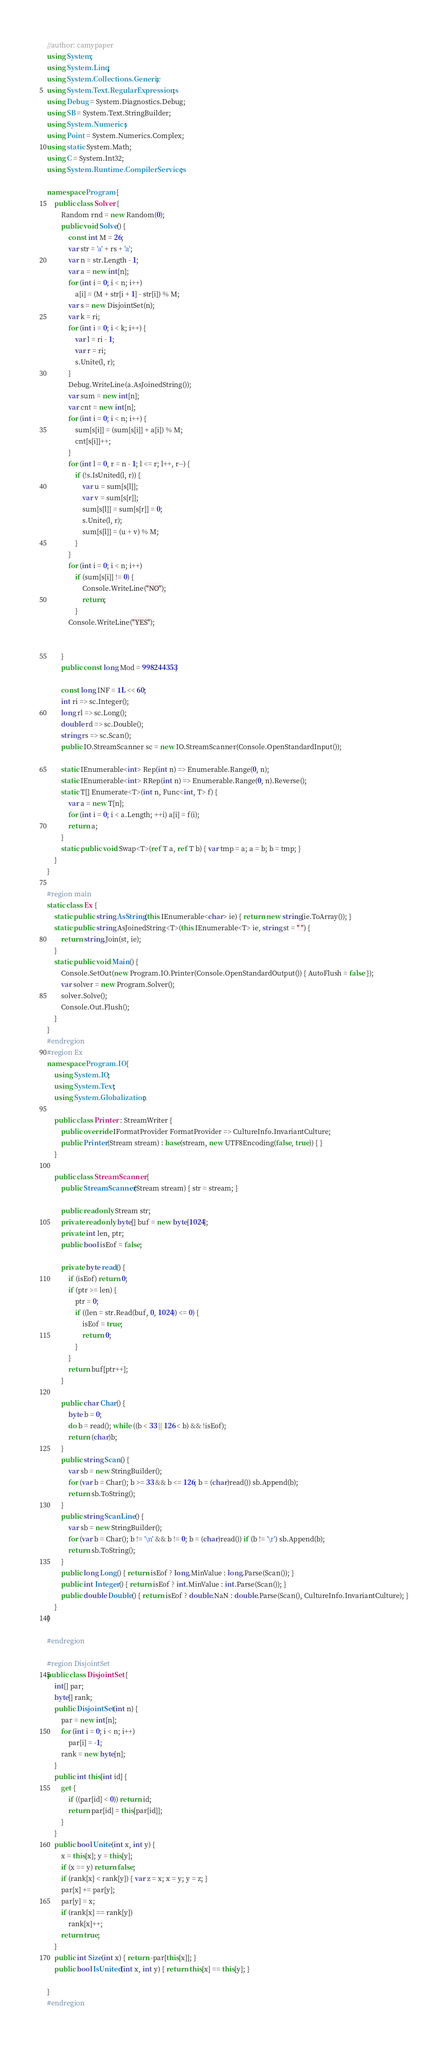Convert code to text. <code><loc_0><loc_0><loc_500><loc_500><_C#_>//author: camypaper
using System;
using System.Linq;
using System.Collections.Generic;
using System.Text.RegularExpressions;
using Debug = System.Diagnostics.Debug;
using SB = System.Text.StringBuilder;
using System.Numerics;
using Point = System.Numerics.Complex;
using static System.Math;
using C = System.Int32;
using System.Runtime.CompilerServices;

namespace Program {
    public class Solver {
        Random rnd = new Random(0);
        public void Solve() {
            const int M = 26;
            var str = 'a' + rs + 'a';
            var n = str.Length - 1;
            var a = new int[n];
            for (int i = 0; i < n; i++)
                a[i] = (M + str[i + 1] - str[i]) % M;
            var s = new DisjointSet(n);
            var k = ri;
            for (int i = 0; i < k; i++) {
                var l = ri - 1;
                var r = ri;
                s.Unite(l, r);
            }
            Debug.WriteLine(a.AsJoinedString());
            var sum = new int[n];
            var cnt = new int[n];
            for (int i = 0; i < n; i++) {
                sum[s[i]] = (sum[s[i]] + a[i]) % M;
                cnt[s[i]]++;
            }
            for (int l = 0, r = n - 1; l <= r; l++, r--) {
                if (!s.IsUnited(l, r)) {
                    var u = sum[s[l]];
                    var v = sum[s[r]];
                    sum[s[l]] = sum[s[r]] = 0;
                    s.Unite(l, r);
                    sum[s[l]] = (u + v) % M;
                }
            }
            for (int i = 0; i < n; i++)
                if (sum[s[i]] != 0) {
                    Console.WriteLine("NO");
                    return;
                }
            Console.WriteLine("YES");


        }
        public const long Mod = 998244353;

        const long INF = 1L << 60;
        int ri => sc.Integer();
        long rl => sc.Long();
        double rd => sc.Double();
        string rs => sc.Scan();
        public IO.StreamScanner sc = new IO.StreamScanner(Console.OpenStandardInput());

        static IEnumerable<int> Rep(int n) => Enumerable.Range(0, n);
        static IEnumerable<int> RRep(int n) => Enumerable.Range(0, n).Reverse();
        static T[] Enumerate<T>(int n, Func<int, T> f) {
            var a = new T[n];
            for (int i = 0; i < a.Length; ++i) a[i] = f(i);
            return a;
        }
        static public void Swap<T>(ref T a, ref T b) { var tmp = a; a = b; b = tmp; }
    }
}

#region main
static class Ex {
    static public string AsString(this IEnumerable<char> ie) { return new string(ie.ToArray()); }
    static public string AsJoinedString<T>(this IEnumerable<T> ie, string st = " ") {
        return string.Join(st, ie);
    }
    static public void Main() {
        Console.SetOut(new Program.IO.Printer(Console.OpenStandardOutput()) { AutoFlush = false });
        var solver = new Program.Solver();
        solver.Solve();
        Console.Out.Flush();
    }
}
#endregion
#region Ex
namespace Program.IO {
    using System.IO;
    using System.Text;
    using System.Globalization;

    public class Printer : StreamWriter {
        public override IFormatProvider FormatProvider => CultureInfo.InvariantCulture;
        public Printer(Stream stream) : base(stream, new UTF8Encoding(false, true)) { }
    }

    public class StreamScanner {
        public StreamScanner(Stream stream) { str = stream; }

        public readonly Stream str;
        private readonly byte[] buf = new byte[1024];
        private int len, ptr;
        public bool isEof = false;

        private byte read() {
            if (isEof) return 0;
            if (ptr >= len) {
                ptr = 0;
                if ((len = str.Read(buf, 0, 1024)) <= 0) {
                    isEof = true;
                    return 0;
                }
            }
            return buf[ptr++];
        }

        public char Char() {
            byte b = 0;
            do b = read(); while ((b < 33 || 126 < b) && !isEof);
            return (char)b;
        }
        public string Scan() {
            var sb = new StringBuilder();
            for (var b = Char(); b >= 33 && b <= 126; b = (char)read()) sb.Append(b);
            return sb.ToString();
        }
        public string ScanLine() {
            var sb = new StringBuilder();
            for (var b = Char(); b != '\n' && b != 0; b = (char)read()) if (b != '\r') sb.Append(b);
            return sb.ToString();
        }
        public long Long() { return isEof ? long.MinValue : long.Parse(Scan()); }
        public int Integer() { return isEof ? int.MinValue : int.Parse(Scan()); }
        public double Double() { return isEof ? double.NaN : double.Parse(Scan(), CultureInfo.InvariantCulture); }
    }
}

#endregion

#region DisjointSet
public class DisjointSet {
    int[] par;
    byte[] rank;
    public DisjointSet(int n) {
        par = new int[n];
        for (int i = 0; i < n; i++)
            par[i] = -1;
        rank = new byte[n];
    }
    public int this[int id] {
        get {
            if ((par[id] < 0)) return id;
            return par[id] = this[par[id]];
        }
    }
    public bool Unite(int x, int y) {
        x = this[x]; y = this[y];
        if (x == y) return false;
        if (rank[x] < rank[y]) { var z = x; x = y; y = z; }
        par[x] += par[y];
        par[y] = x;
        if (rank[x] == rank[y])
            rank[x]++;
        return true;
    }
    public int Size(int x) { return -par[this[x]]; }
    public bool IsUnited(int x, int y) { return this[x] == this[y]; }

}
#endregion</code> 